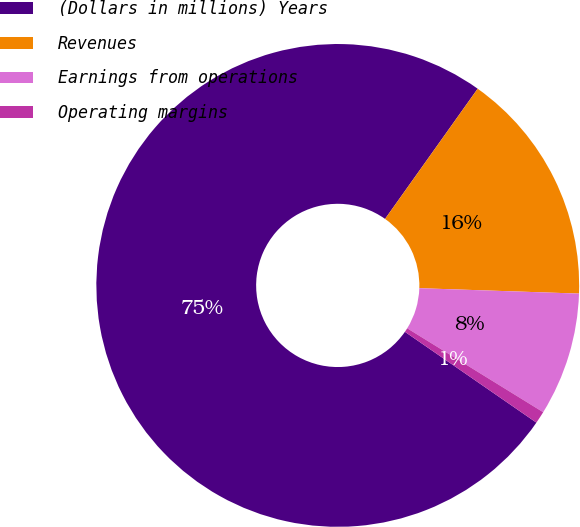Convert chart. <chart><loc_0><loc_0><loc_500><loc_500><pie_chart><fcel>(Dollars in millions) Years<fcel>Revenues<fcel>Earnings from operations<fcel>Operating margins<nl><fcel>75.22%<fcel>15.7%<fcel>8.26%<fcel>0.82%<nl></chart> 